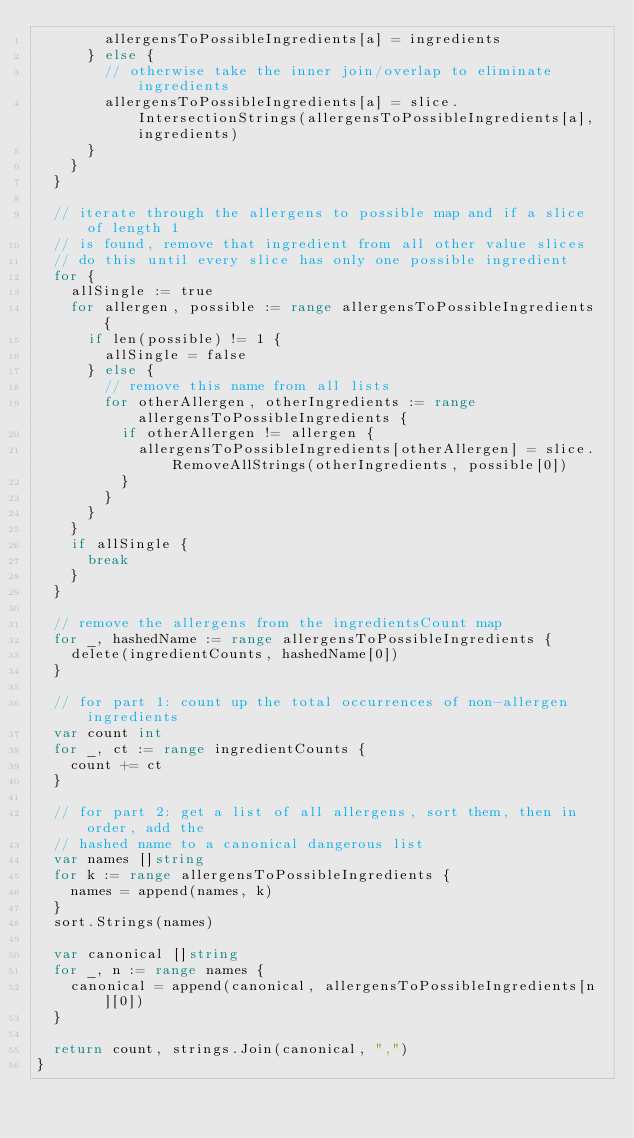<code> <loc_0><loc_0><loc_500><loc_500><_Go_>				allergensToPossibleIngredients[a] = ingredients
			} else {
				// otherwise take the inner join/overlap to eliminate ingredients
				allergensToPossibleIngredients[a] = slice.IntersectionStrings(allergensToPossibleIngredients[a], ingredients)
			}
		}
	}

	// iterate through the allergens to possible map and if a slice of length 1
	// is found, remove that ingredient from all other value slices
	// do this until every slice has only one possible ingredient
	for {
		allSingle := true
		for allergen, possible := range allergensToPossibleIngredients {
			if len(possible) != 1 {
				allSingle = false
			} else {
				// remove this name from all lists
				for otherAllergen, otherIngredients := range allergensToPossibleIngredients {
					if otherAllergen != allergen {
						allergensToPossibleIngredients[otherAllergen] = slice.RemoveAllStrings(otherIngredients, possible[0])
					}
				}
			}
		}
		if allSingle {
			break
		}
	}

	// remove the allergens from the ingredientsCount map
	for _, hashedName := range allergensToPossibleIngredients {
		delete(ingredientCounts, hashedName[0])
	}

	// for part 1: count up the total occurrences of non-allergen ingredients
	var count int
	for _, ct := range ingredientCounts {
		count += ct
	}

	// for part 2: get a list of all allergens, sort them, then in order, add the
	// hashed name to a canonical dangerous list
	var names []string
	for k := range allergensToPossibleIngredients {
		names = append(names, k)
	}
	sort.Strings(names)

	var canonical []string
	for _, n := range names {
		canonical = append(canonical, allergensToPossibleIngredients[n][0])
	}

	return count, strings.Join(canonical, ",")
}
</code> 